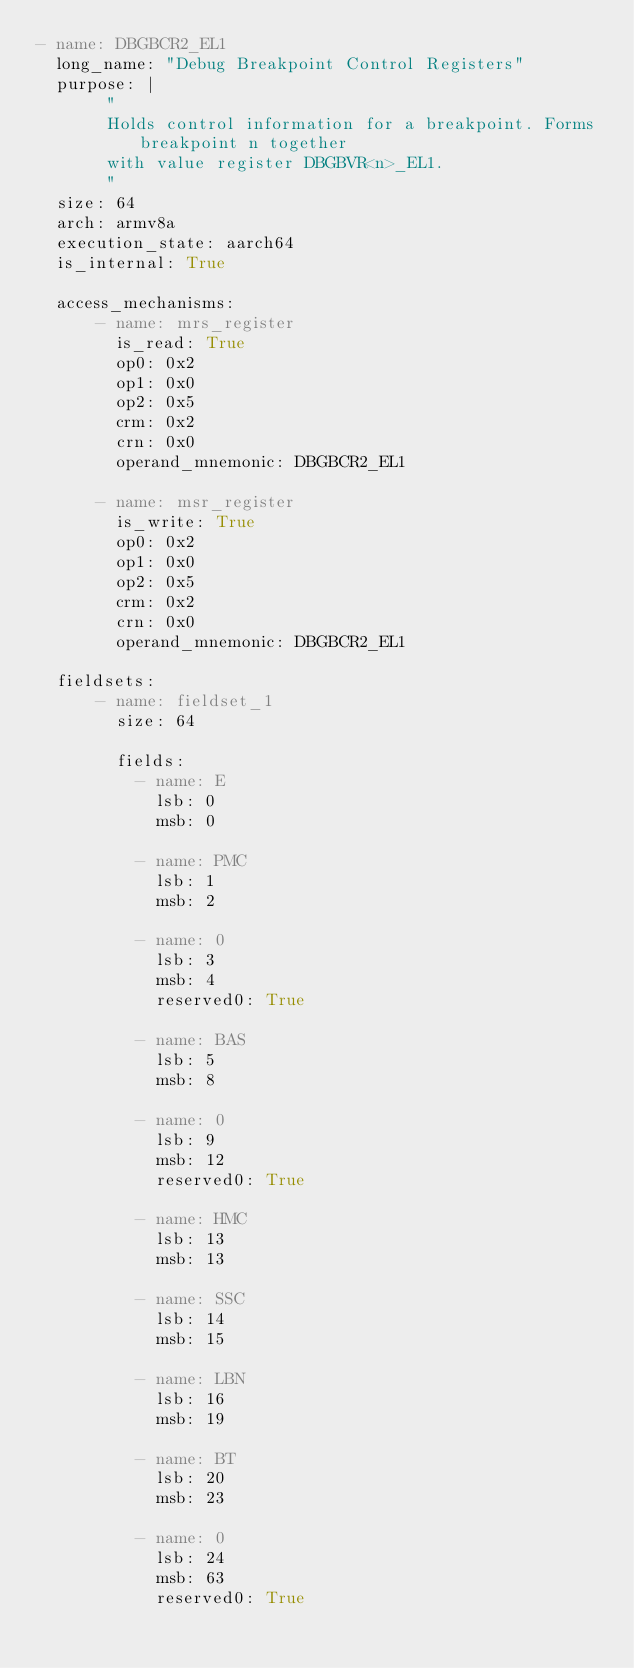<code> <loc_0><loc_0><loc_500><loc_500><_YAML_>- name: DBGBCR2_EL1
  long_name: "Debug Breakpoint Control Registers"
  purpose: |
       "
       Holds control information for a breakpoint. Forms breakpoint n together
       with value register DBGBVR<n>_EL1.
       "
  size: 64
  arch: armv8a
  execution_state: aarch64
  is_internal: True

  access_mechanisms:
      - name: mrs_register
        is_read: True
        op0: 0x2
        op1: 0x0
        op2: 0x5
        crm: 0x2
        crn: 0x0
        operand_mnemonic: DBGBCR2_EL1

      - name: msr_register
        is_write: True
        op0: 0x2
        op1: 0x0
        op2: 0x5
        crm: 0x2
        crn: 0x0
        operand_mnemonic: DBGBCR2_EL1

  fieldsets:
      - name: fieldset_1
        size: 64

        fields:
          - name: E
            lsb: 0
            msb: 0

          - name: PMC
            lsb: 1
            msb: 2

          - name: 0
            lsb: 3
            msb: 4
            reserved0: True

          - name: BAS
            lsb: 5
            msb: 8

          - name: 0
            lsb: 9
            msb: 12
            reserved0: True

          - name: HMC
            lsb: 13
            msb: 13

          - name: SSC
            lsb: 14
            msb: 15

          - name: LBN
            lsb: 16
            msb: 19

          - name: BT
            lsb: 20
            msb: 23

          - name: 0
            lsb: 24
            msb: 63
            reserved0: True
</code> 